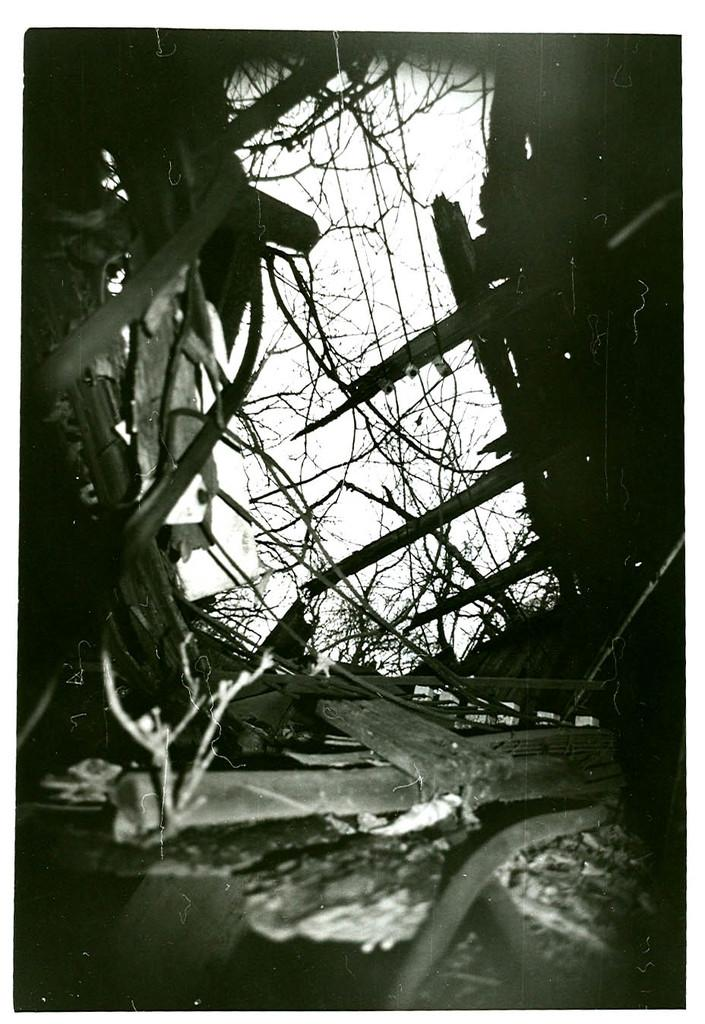What is the color scheme of the image? The image is black and white. What objects can be seen on the ground in the image? There are wooden sticks on the ground in the image. What structure is present at the bottom of the image? There is a pipe at the bottom of the image. Are there any wooden sticks located elsewhere in the image? Yes, there are wooden sticks on either side of the image. What type of badge can be seen on the pipe in the image? There is no badge present on the pipe in the image. What kind of flowers are growing near the wooden sticks on the left side of the image? There are no flowers present in the image; it is a black and white image with wooden sticks and a pipe. 